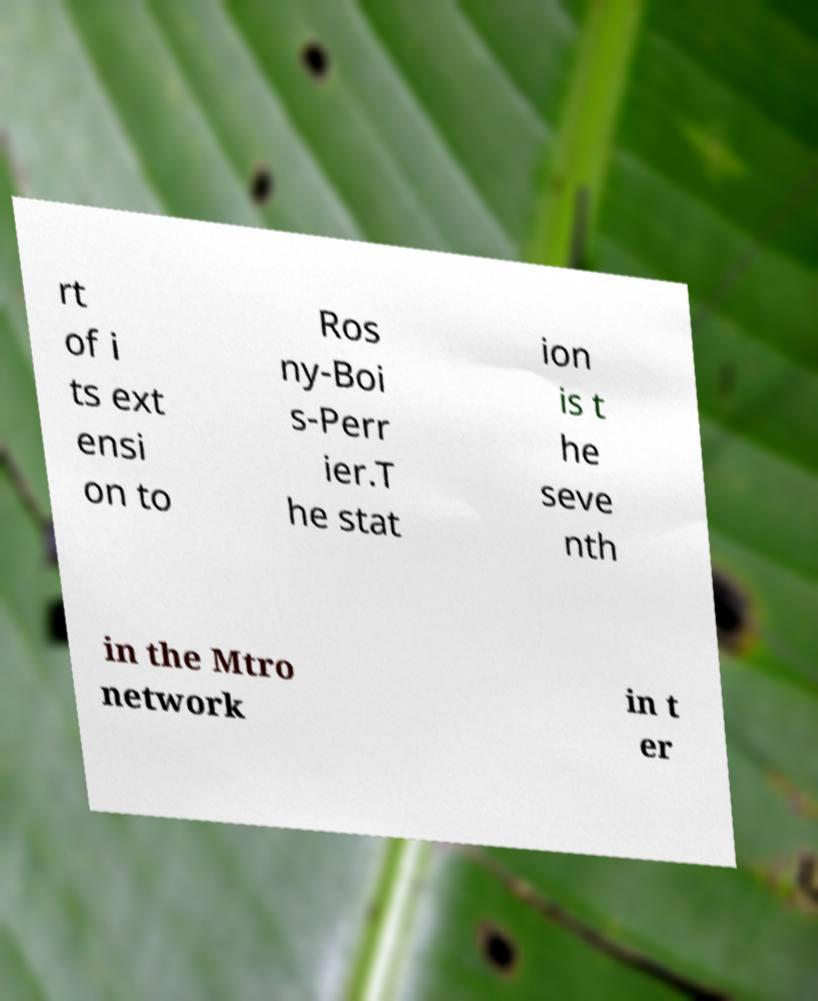Please identify and transcribe the text found in this image. rt of i ts ext ensi on to Ros ny-Boi s-Perr ier.T he stat ion is t he seve nth in the Mtro network in t er 